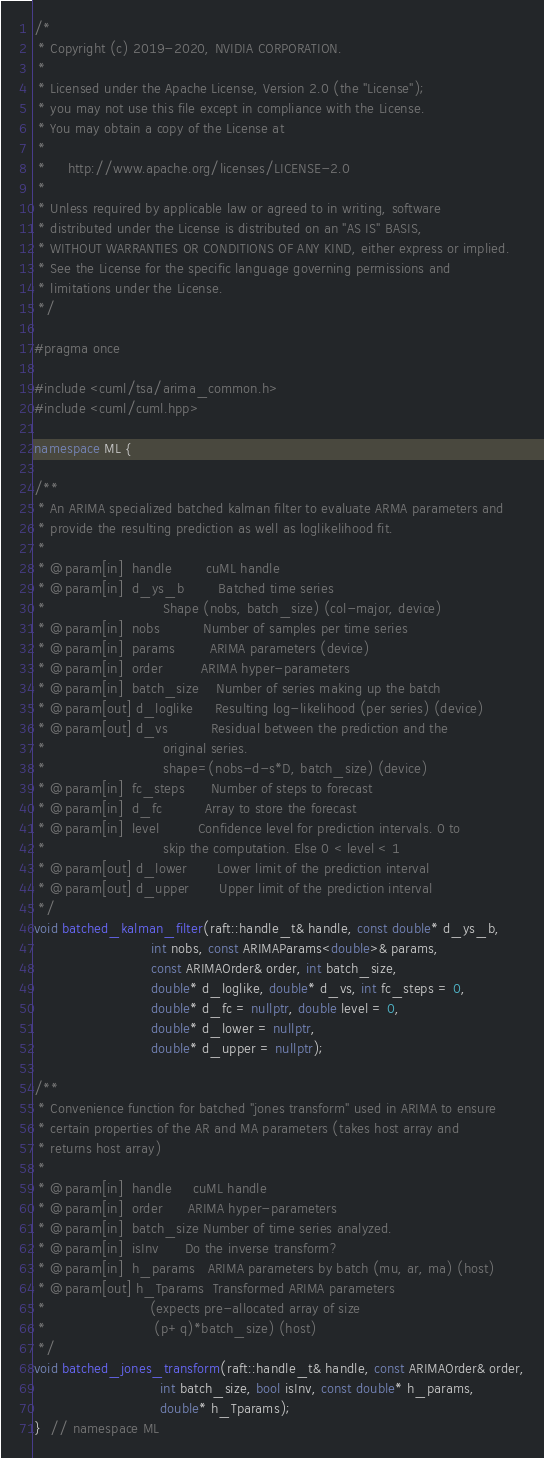<code> <loc_0><loc_0><loc_500><loc_500><_C++_>/*
 * Copyright (c) 2019-2020, NVIDIA CORPORATION.
 *
 * Licensed under the Apache License, Version 2.0 (the "License");
 * you may not use this file except in compliance with the License.
 * You may obtain a copy of the License at
 *
 *     http://www.apache.org/licenses/LICENSE-2.0
 *
 * Unless required by applicable law or agreed to in writing, software
 * distributed under the License is distributed on an "AS IS" BASIS,
 * WITHOUT WARRANTIES OR CONDITIONS OF ANY KIND, either express or implied.
 * See the License for the specific language governing permissions and
 * limitations under the License.
 */

#pragma once

#include <cuml/tsa/arima_common.h>
#include <cuml/cuml.hpp>

namespace ML {

/**
 * An ARIMA specialized batched kalman filter to evaluate ARMA parameters and
 * provide the resulting prediction as well as loglikelihood fit.
 *
 * @param[in]  handle        cuML handle
 * @param[in]  d_ys_b        Batched time series
 *                           Shape (nobs, batch_size) (col-major, device)
 * @param[in]  nobs          Number of samples per time series
 * @param[in]  params        ARIMA parameters (device)
 * @param[in]  order         ARIMA hyper-parameters
 * @param[in]  batch_size    Number of series making up the batch
 * @param[out] d_loglike     Resulting log-likelihood (per series) (device)
 * @param[out] d_vs          Residual between the prediction and the
 *                           original series.
 *                           shape=(nobs-d-s*D, batch_size) (device)
 * @param[in]  fc_steps      Number of steps to forecast
 * @param[in]  d_fc          Array to store the forecast
 * @param[in]  level         Confidence level for prediction intervals. 0 to
 *                           skip the computation. Else 0 < level < 1
 * @param[out] d_lower       Lower limit of the prediction interval
 * @param[out] d_upper       Upper limit of the prediction interval
 */
void batched_kalman_filter(raft::handle_t& handle, const double* d_ys_b,
                           int nobs, const ARIMAParams<double>& params,
                           const ARIMAOrder& order, int batch_size,
                           double* d_loglike, double* d_vs, int fc_steps = 0,
                           double* d_fc = nullptr, double level = 0,
                           double* d_lower = nullptr,
                           double* d_upper = nullptr);

/**
 * Convenience function for batched "jones transform" used in ARIMA to ensure
 * certain properties of the AR and MA parameters (takes host array and
 * returns host array)
 *
 * @param[in]  handle     cuML handle
 * @param[in]  order      ARIMA hyper-parameters
 * @param[in]  batch_size Number of time series analyzed.
 * @param[in]  isInv      Do the inverse transform?
 * @param[in]  h_params   ARIMA parameters by batch (mu, ar, ma) (host)
 * @param[out] h_Tparams  Transformed ARIMA parameters
 *                        (expects pre-allocated array of size
 *                         (p+q)*batch_size) (host)
 */
void batched_jones_transform(raft::handle_t& handle, const ARIMAOrder& order,
                             int batch_size, bool isInv, const double* h_params,
                             double* h_Tparams);
}  // namespace ML
</code> 